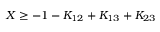Convert formula to latex. <formula><loc_0><loc_0><loc_500><loc_500>X \geq - 1 - K _ { 1 2 } + K _ { 1 3 } + K _ { 2 3 }</formula> 